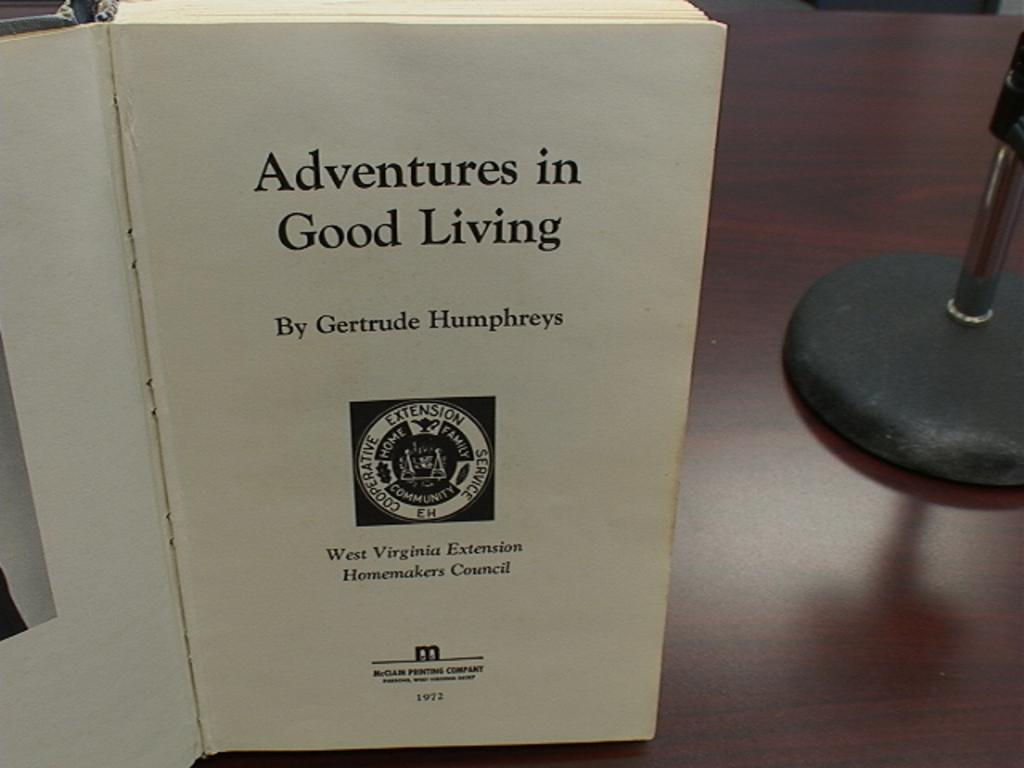Provide a one-sentence caption for the provided image. First page of a book named "Adventures in Good Living". 